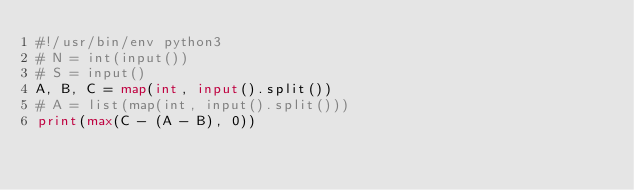<code> <loc_0><loc_0><loc_500><loc_500><_Python_>#!/usr/bin/env python3
# N = int(input())
# S = input()
A, B, C = map(int, input().split())
# A = list(map(int, input().split()))
print(max(C - (A - B), 0))</code> 